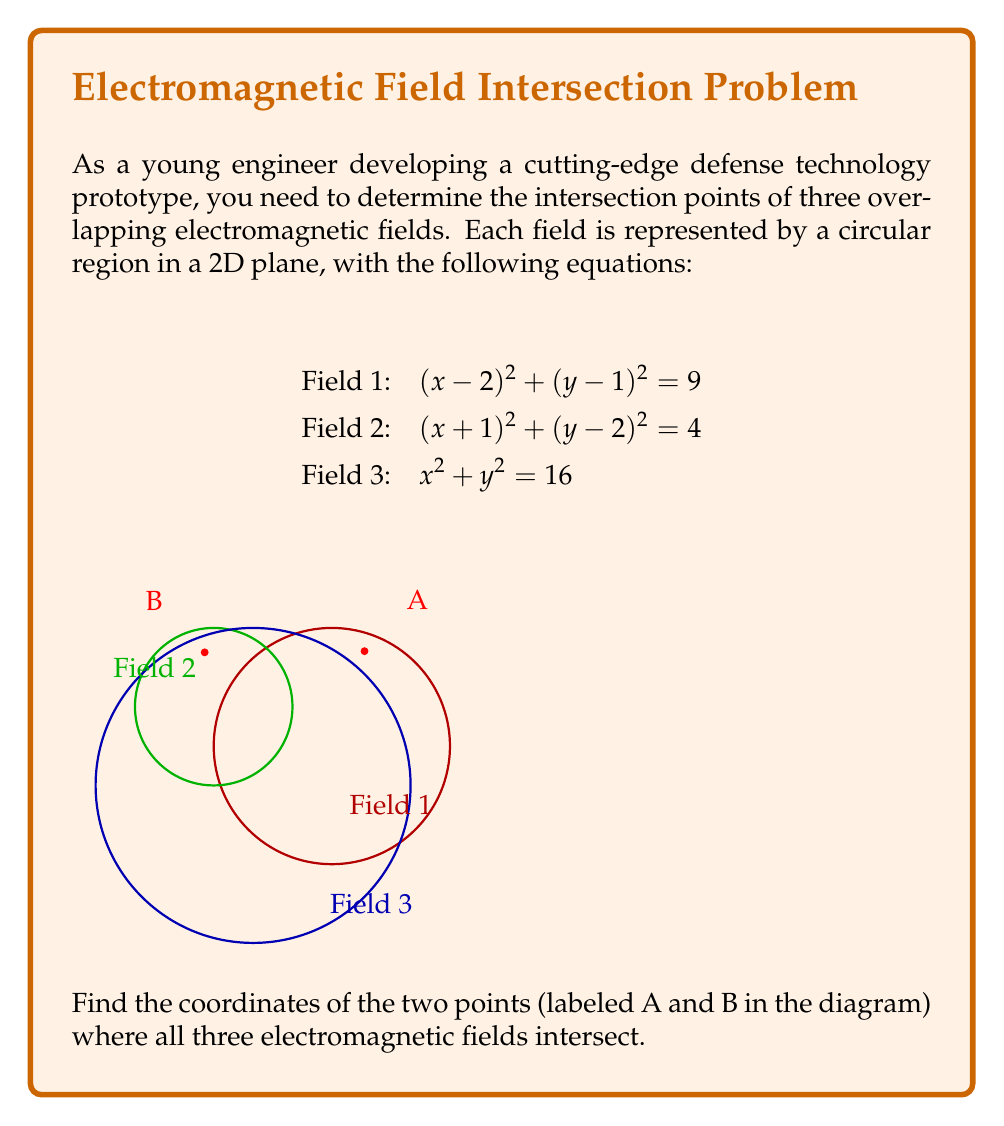Show me your answer to this math problem. To find the intersection points of all three electromagnetic fields, we need to solve the system of equations:

1) $$(x-2)^2 + (y-1)^2 = 9$$
2) $$(x+1)^2 + (y-2)^2 = 4$$
3) $$x^2 + y^2 = 16$$

Step 1: Subtract equation 2 from equation 1 to eliminate the squared terms:
$$(x-2)^2 - (x+1)^2 + (y-1)^2 - (y-2)^2 = 9 - 4$$
$$-6x + 3y = 0$$
$$2x = y$$

Step 2: Substitute $y = 2x$ into equation 3:
$$x^2 + (2x)^2 = 16$$
$$x^2 + 4x^2 = 16$$
$$5x^2 = 16$$
$$x^2 = \frac{16}{5}$$

Step 3: Solve for x:
$$x = \pm \sqrt{\frac{16}{5}} = \pm \frac{4}{\sqrt{5}}$$

Step 4: Calculate y using $y = 2x$:
$$y = \pm \frac{8}{\sqrt{5}}$$

Step 5: Check which points satisfy all three equations:

Point A: $$(\frac{4}{\sqrt{5}}, \frac{8}{\sqrt{5}}) \approx (1.79, 3.58)$$
Point B: $$(-\frac{4}{\sqrt{5}}, -\frac{8}{\sqrt{5}}) \approx (-1.79, -3.58)$$

Only Point A satisfies all three equations. To find the second intersection point, we need to solve the system again with $y = -2x$ instead of $y = 2x$.

Step 6: Substitute $y = -2x$ into equation 3:
$$x^2 + (-2x)^2 = 16$$
$$5x^2 = 16$$
$$x^2 = \frac{16}{5}$$

Step 7: Solve for x and y:
$$x = \pm \frac{4}{\sqrt{5}}$$
$$y = \mp \frac{8}{\sqrt{5}}$$

Point B: $$(-\frac{4}{\sqrt{5}}, \frac{8}{\sqrt{5}}) \approx (-1.79, 3.58)$$

Therefore, the two intersection points are:
A: $$(\frac{4}{\sqrt{5}}, \frac{8}{\sqrt{5}})$$
B: $$(-\frac{4}{\sqrt{5}}, \frac{8}{\sqrt{5}})$$
Answer: $$(\frac{4}{\sqrt{5}}, \frac{8}{\sqrt{5}})$$ and $$(-\frac{4}{\sqrt{5}}, \frac{8}{\sqrt{5}})$$ 